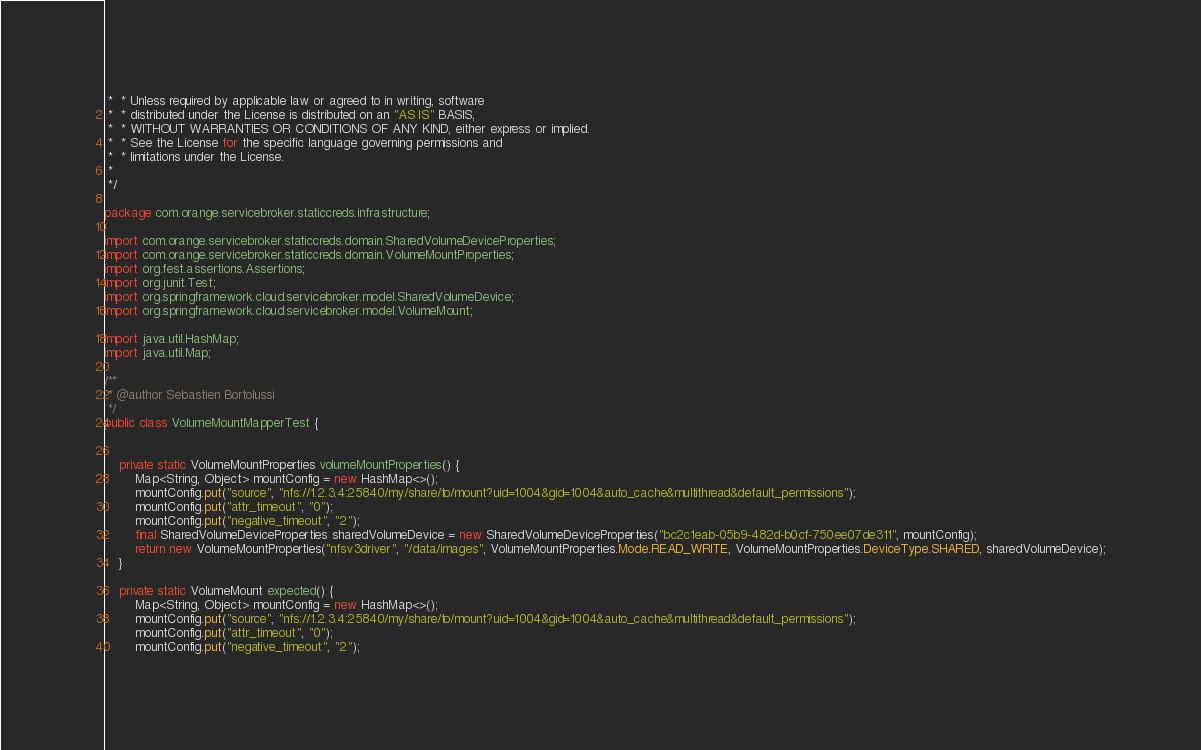Convert code to text. <code><loc_0><loc_0><loc_500><loc_500><_Java_> *  * Unless required by applicable law or agreed to in writing, software
 *  * distributed under the License is distributed on an "AS IS" BASIS,
 *  * WITHOUT WARRANTIES OR CONDITIONS OF ANY KIND, either express or implied.
 *  * See the License for the specific language governing permissions and
 *  * limitations under the License.
 *
 */

package com.orange.servicebroker.staticcreds.infrastructure;

import com.orange.servicebroker.staticcreds.domain.SharedVolumeDeviceProperties;
import com.orange.servicebroker.staticcreds.domain.VolumeMountProperties;
import org.fest.assertions.Assertions;
import org.junit.Test;
import org.springframework.cloud.servicebroker.model.SharedVolumeDevice;
import org.springframework.cloud.servicebroker.model.VolumeMount;

import java.util.HashMap;
import java.util.Map;

/**
 * @author Sebastien Bortolussi
 */
public class VolumeMountMapperTest {


    private static VolumeMountProperties volumeMountProperties() {
        Map<String, Object> mountConfig = new HashMap<>();
        mountConfig.put("source", "nfs://1.2.3.4:25840/my/share/to/mount?uid=1004&gid=1004&auto_cache&multithread&default_permissions");
        mountConfig.put("attr_timeout", "0");
        mountConfig.put("negative_timeout", "2");
        final SharedVolumeDeviceProperties sharedVolumeDevice = new SharedVolumeDeviceProperties("bc2c1eab-05b9-482d-b0cf-750ee07de311", mountConfig);
        return new VolumeMountProperties("nfsv3driver", "/data/images", VolumeMountProperties.Mode.READ_WRITE, VolumeMountProperties.DeviceType.SHARED, sharedVolumeDevice);
    }

    private static VolumeMount expected() {
        Map<String, Object> mountConfig = new HashMap<>();
        mountConfig.put("source", "nfs://1.2.3.4:25840/my/share/to/mount?uid=1004&gid=1004&auto_cache&multithread&default_permissions");
        mountConfig.put("attr_timeout", "0");
        mountConfig.put("negative_timeout", "2");</code> 